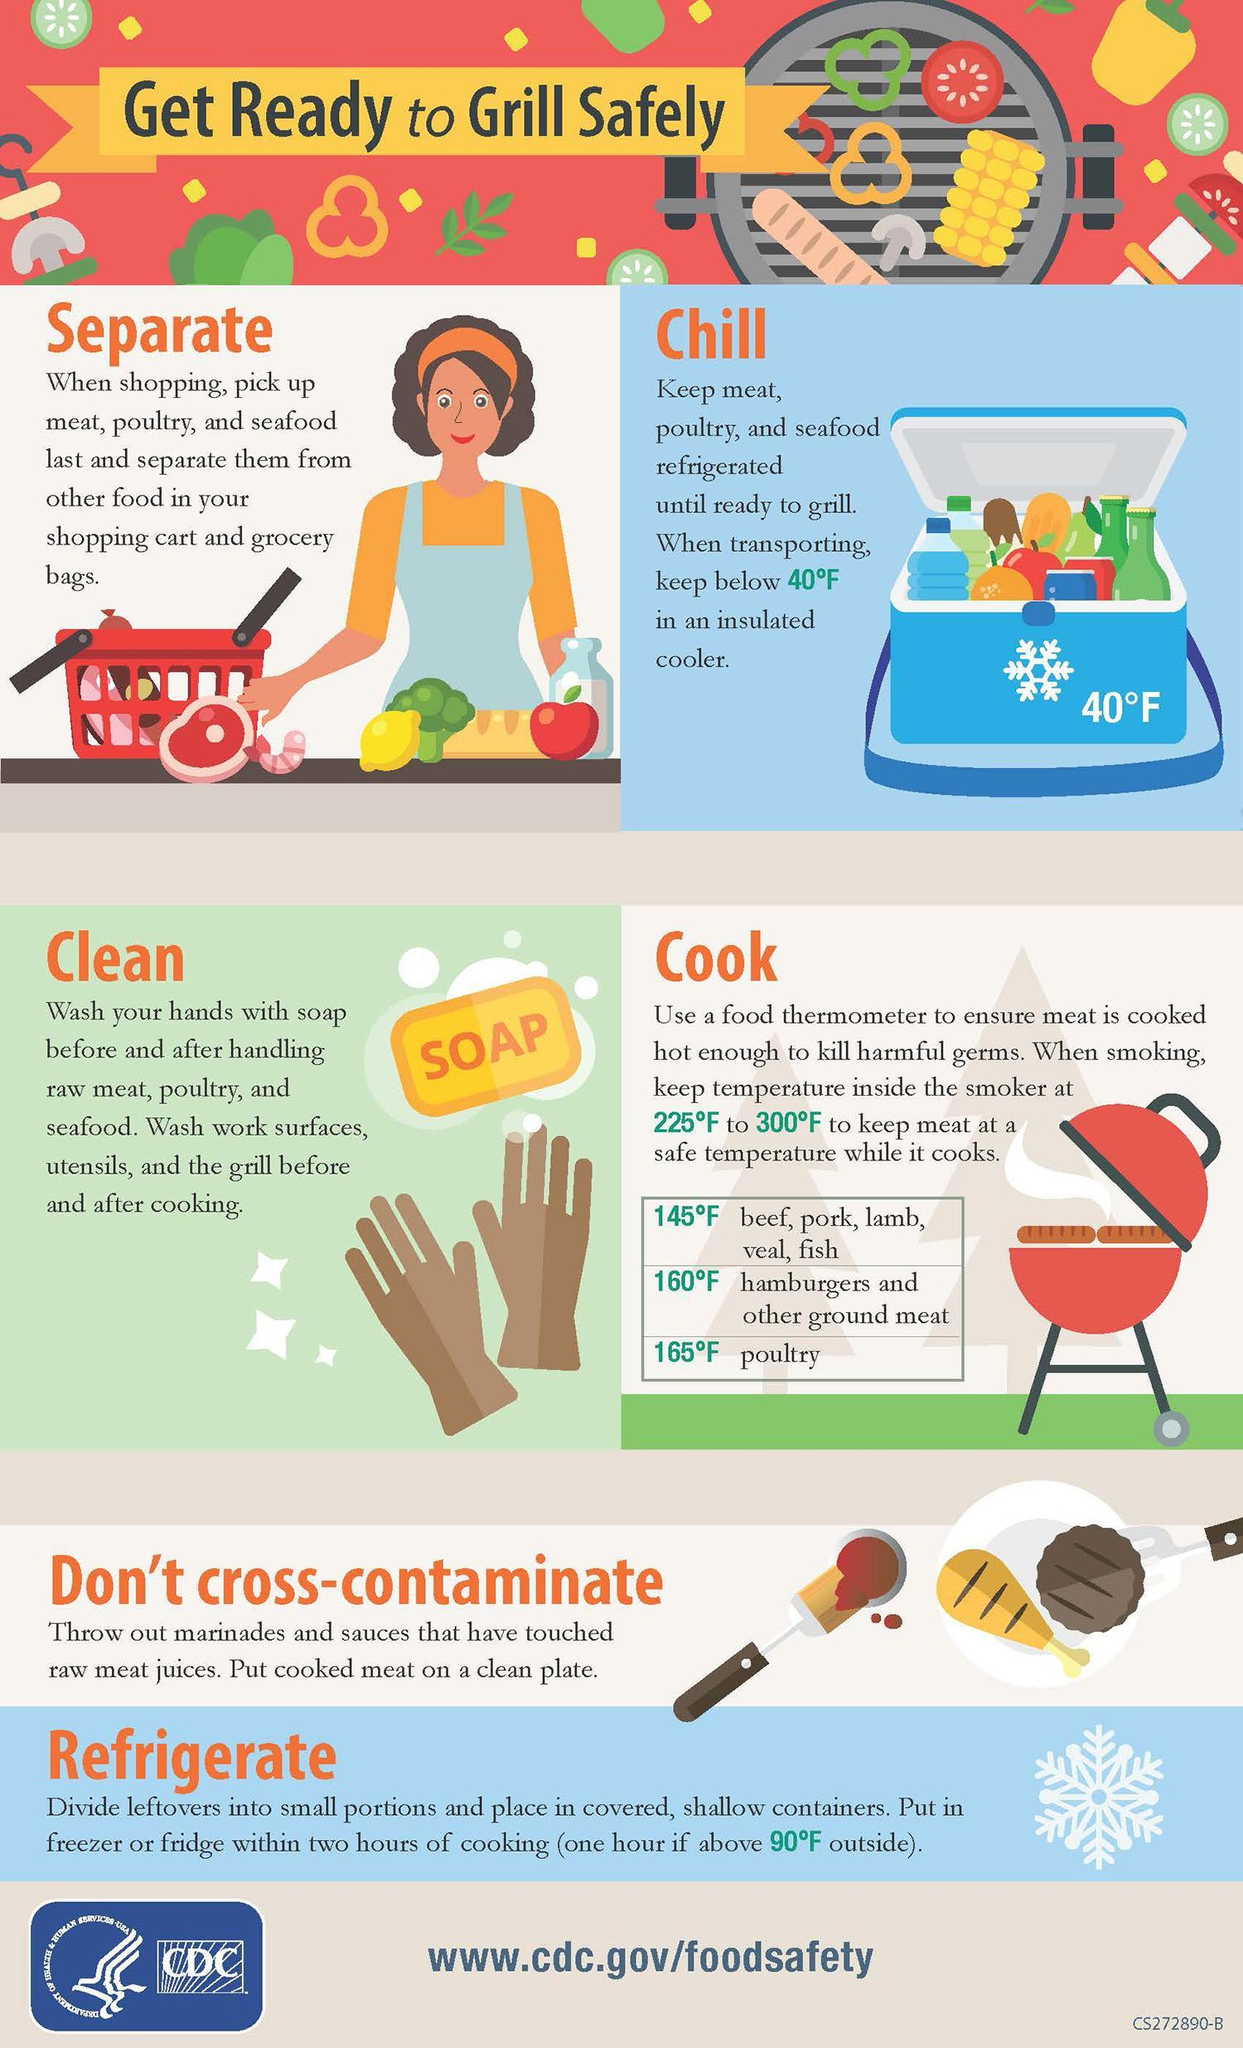What is written inside the yellow rectangle near the image of two hands?
Answer the question with a short phrase. SOAP What is the temperature written on the blue insulated cooler in Fahrenheits? 40 How many steps are to be followed for grilling food safely? 6 What is the safe temperatures to cook fish in Fahrenheits, 145, 160, or 165? 145 